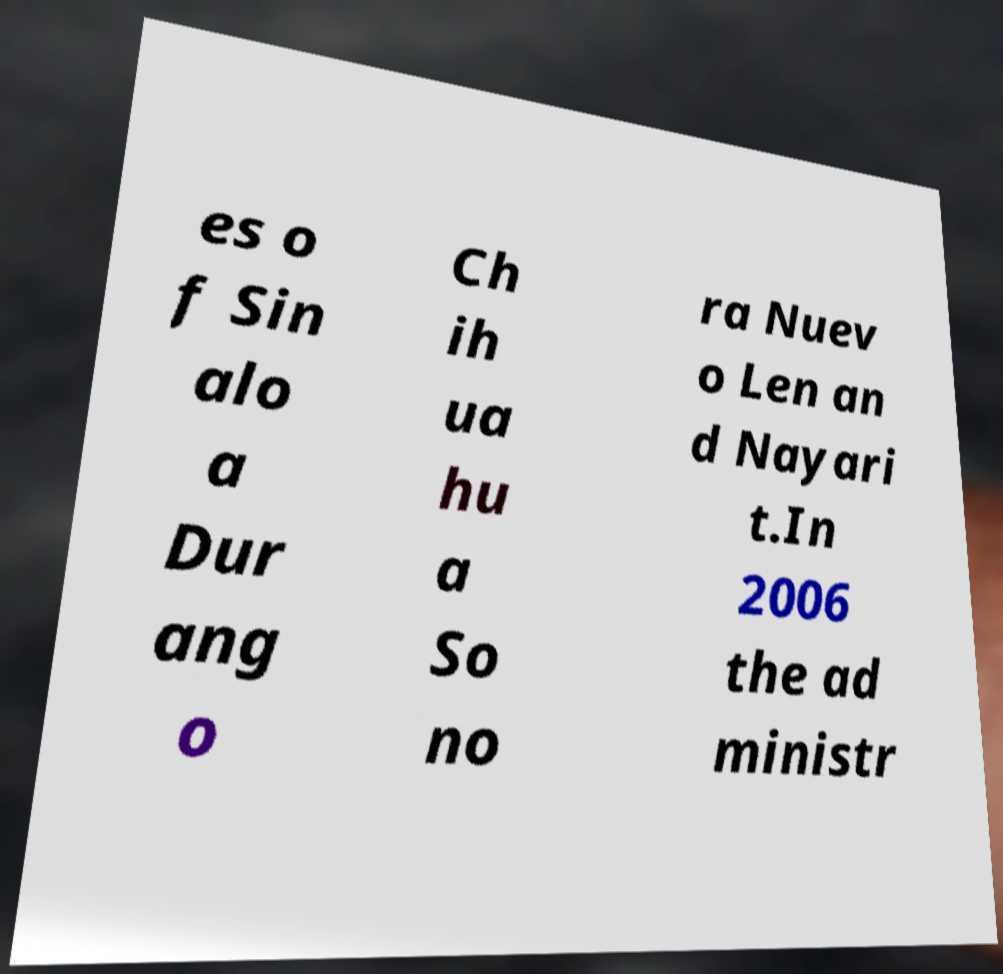Could you assist in decoding the text presented in this image and type it out clearly? es o f Sin alo a Dur ang o Ch ih ua hu a So no ra Nuev o Len an d Nayari t.In 2006 the ad ministr 